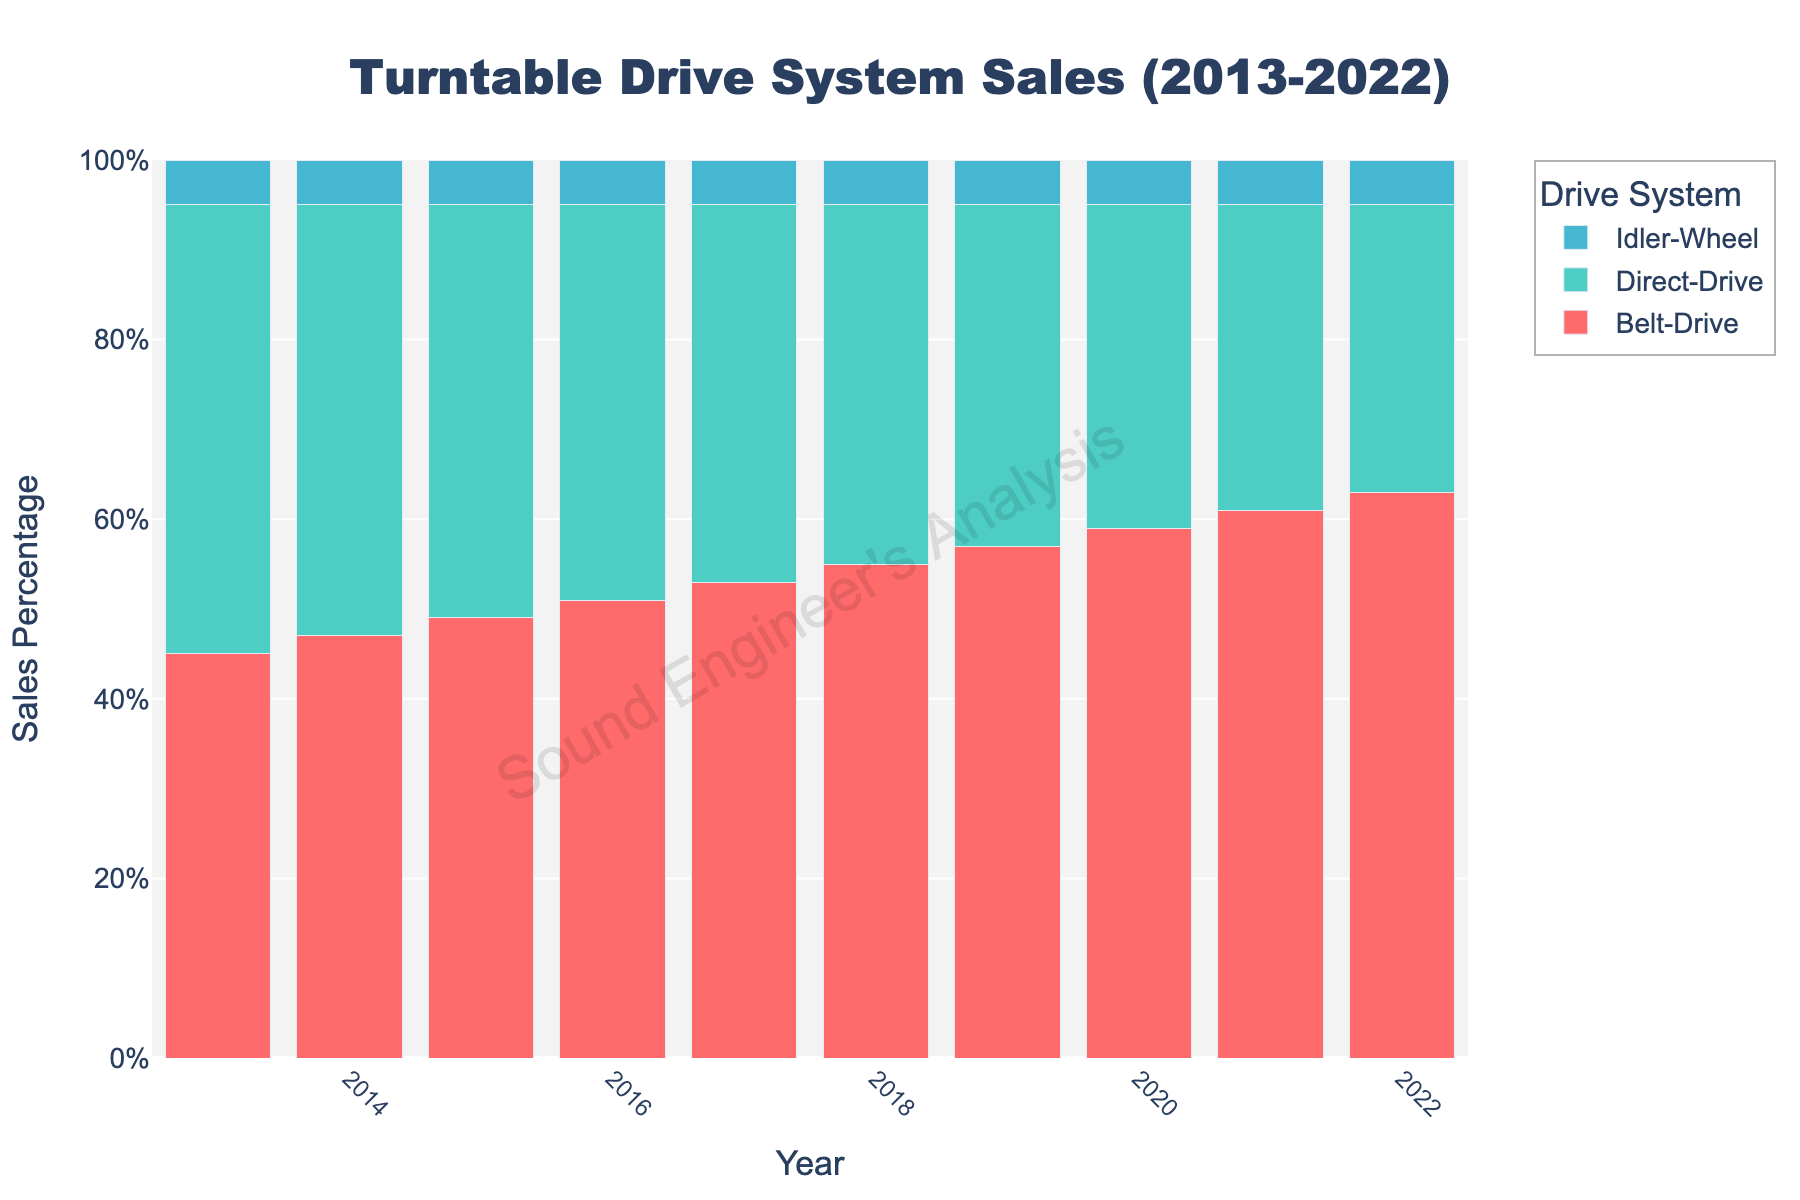What is the general trend of Belt-Drive sales over the decade? To see the general trend, observe the heights of the red bars for Belt-Drive from 2013 to 2022. They increase consistently over the years.
Answer: Increasing In which year did Direct-Drive sales surpass Belt-Drive sales? Compare the heights of the green bars (Direct-Drive) to the red bars (Belt-Drive). In 2013, the green bar is taller. From 2014 onwards, the red bars are taller.
Answer: 2013 Which drive system had the most stable sales over the decade? Compare the heights of the bars across all years for each drive system. The blue bars (Idler-Wheel) are the most consistent.
Answer: Idler-Wheel What is the difference in sales between Belt-Drive and Direct-Drive in 2022? Locate the heights of the red bar (Belt-Drive) and green bar (Direct-Drive) in 2022. Belt-Drive is 63% and Direct-Drive is 32%. The difference is 63% - 32% = 31%.
Answer: 31% Which year had the highest total sales for all drive systems? Add the heights of the bars for each year and compare. The values are 100% each year.
Answer: All years Calculate the average sales percentage for Idler-Wheel across the decade. The sales percentage for Idler-Wheel is 5% each year. Add them up and divide by the number of years (10). (5% * 10) / 10 = 5%
Answer: 5% How does the sales trend of Direct-Drive compare to that of Belt-Drive? Observe the trend lines for both drive systems. Direct-Drive sales decreased while Belt-Drive sales increased.
Answer: Decreasing vs Increasing What was the combined sales percentage of Idler-Wheel and Belt-Drive in 2016? Add the percentages of the blue bar (Idler-Wheel) and the red bar (Belt-Drive) for 2016. 5% + 51% = 56%
Answer: 56% In which year did Belt-Drive sales cross the 50% mark? Check the heights of the red bars to see when they exceeded 50%. This occurs in 2016.
Answer: 2016 Between 2013 and 2022, how many times did Direct-Drive sales decrease year-over-year? Count the drops in the heights of the green bars year-over-year. Sales decreased every year from 2013 to 2022.
Answer: 9 